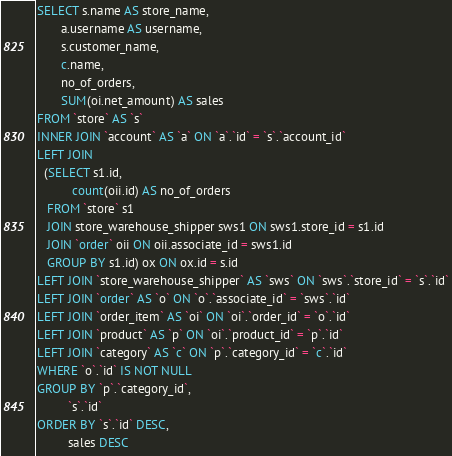Convert code to text. <code><loc_0><loc_0><loc_500><loc_500><_SQL_>SELECT s.name AS store_name,
       a.username AS username,
       s.customer_name,
       c.name,
       no_of_orders,
       SUM(oi.net_amount) AS sales
FROM `store` AS `s`
INNER JOIN `account` AS `a` ON `a`.`id` = `s`.`account_id`
LEFT JOIN
  (SELECT s1.id,
          count(oii.id) AS no_of_orders
   FROM `store` s1
   JOIN store_warehouse_shipper sws1 ON sws1.store_id = s1.id
   JOIN `order` oii ON oii.associate_id = sws1.id
   GROUP BY s1.id) ox ON ox.id = s.id
LEFT JOIN `store_warehouse_shipper` AS `sws` ON `sws`.`store_id` = `s`.`id`
LEFT JOIN `order` AS `o` ON `o`.`associate_id` = `sws`.`id`
LEFT JOIN `order_item` AS `oi` ON `oi`.`order_id` = `o`.`id`
LEFT JOIN `product` AS `p` ON `oi`.`product_id` = `p`.`id`
LEFT JOIN `category` AS `c` ON `p`.`category_id` = `c`.`id`
WHERE `o`.`id` IS NOT NULL
GROUP BY `p`.`category_id`,
         `s`.`id`
ORDER BY `s`.`id` DESC,
         sales DESC</code> 